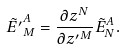<formula> <loc_0><loc_0><loc_500><loc_500>\tilde { E ^ { \prime } } _ { M } ^ { A } = \frac { \partial { z } ^ { N } } { \partial { z ^ { \prime } } ^ { M } } \tilde { E } _ { N } ^ { A } .</formula> 